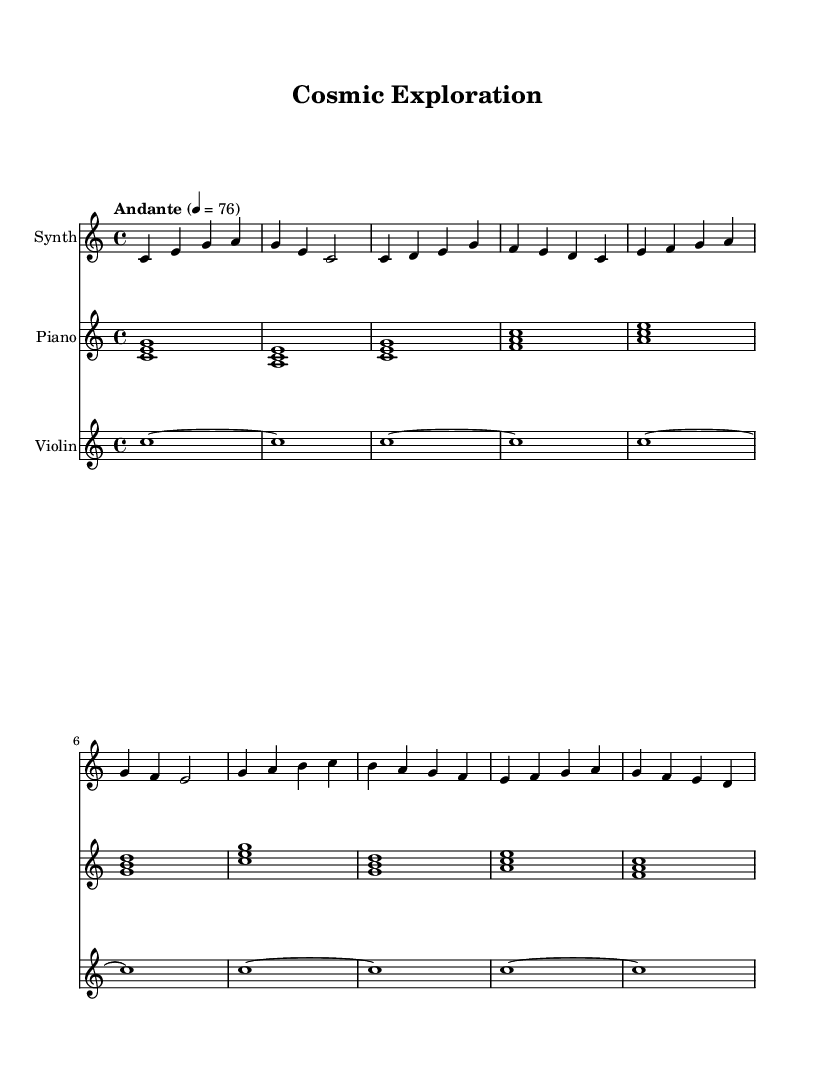What is the key signature of this music? The key signature of the piece is C major, indicated by the absence of sharps or flats in the staff.
Answer: C major What is the time signature of this music? The time signature is 4/4, represented by the two numbers at the beginning of the score, indicating four beats per measure with a quarter note receiving one beat.
Answer: 4/4 What is the tempo marking? The tempo marking is "Andante," which suggests a moderate pace and is often interpreted as walking speed.
Answer: Andante How many measures are in the chorus section? The chorus section has four measures, identifiable by the layout and the music that corresponds to the "Chorus" label.
Answer: 4 Which instrument plays the synthesizer part? The instrument designated as "Synth" plays the synthesizer part, as indicated by the label above the staff in the score.
Answer: Synth How many different instruments are featured in this sheet music? There are three instruments featured: synthesizer, piano, and violin, each represented by separate staves within the score.
Answer: 3 What is the last note of the chorus section? The last note of the chorus is a D note, found in the final measure of the chorus section in the synthesizer part.
Answer: D 